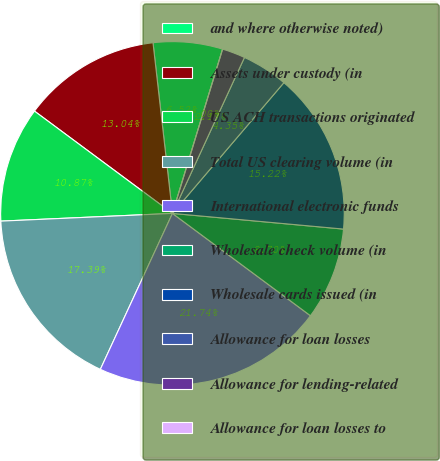Convert chart to OTSL. <chart><loc_0><loc_0><loc_500><loc_500><pie_chart><fcel>and where otherwise noted)<fcel>Assets under custody (in<fcel>US ACH transactions originated<fcel>Total US clearing volume (in<fcel>International electronic funds<fcel>Wholesale check volume (in<fcel>Wholesale cards issued (in<fcel>Allowance for loan losses<fcel>Allowance for lending-related<fcel>Allowance for loan losses to<nl><fcel>6.52%<fcel>13.04%<fcel>10.87%<fcel>17.39%<fcel>21.74%<fcel>8.7%<fcel>15.22%<fcel>4.35%<fcel>2.17%<fcel>0.0%<nl></chart> 